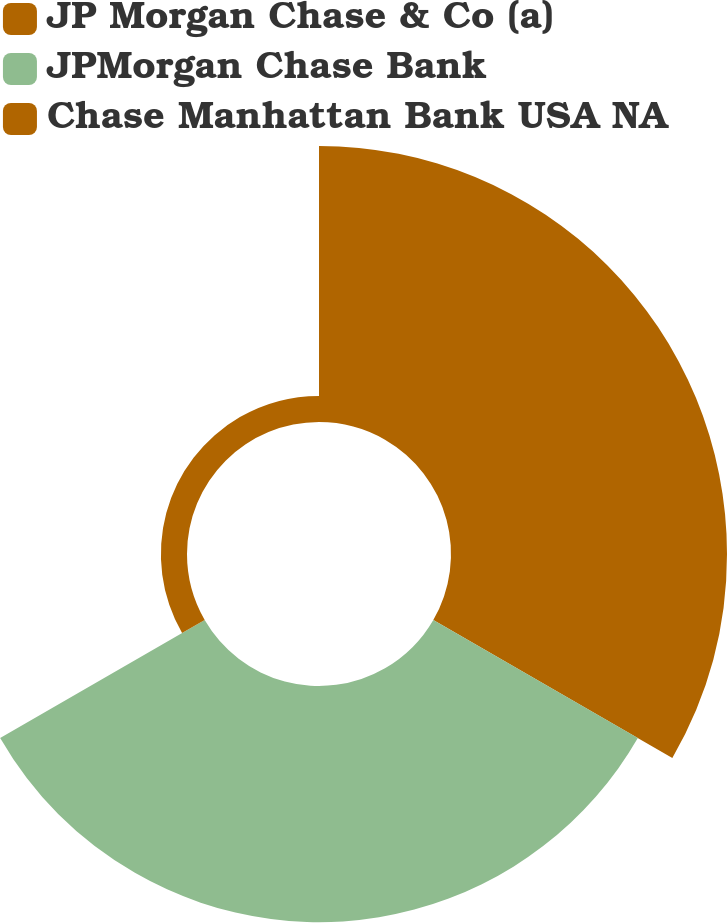Convert chart. <chart><loc_0><loc_0><loc_500><loc_500><pie_chart><fcel>JP Morgan Chase & Co (a)<fcel>JPMorgan Chase Bank<fcel>Chase Manhattan Bank USA NA<nl><fcel>51.27%<fcel>43.87%<fcel>4.85%<nl></chart> 